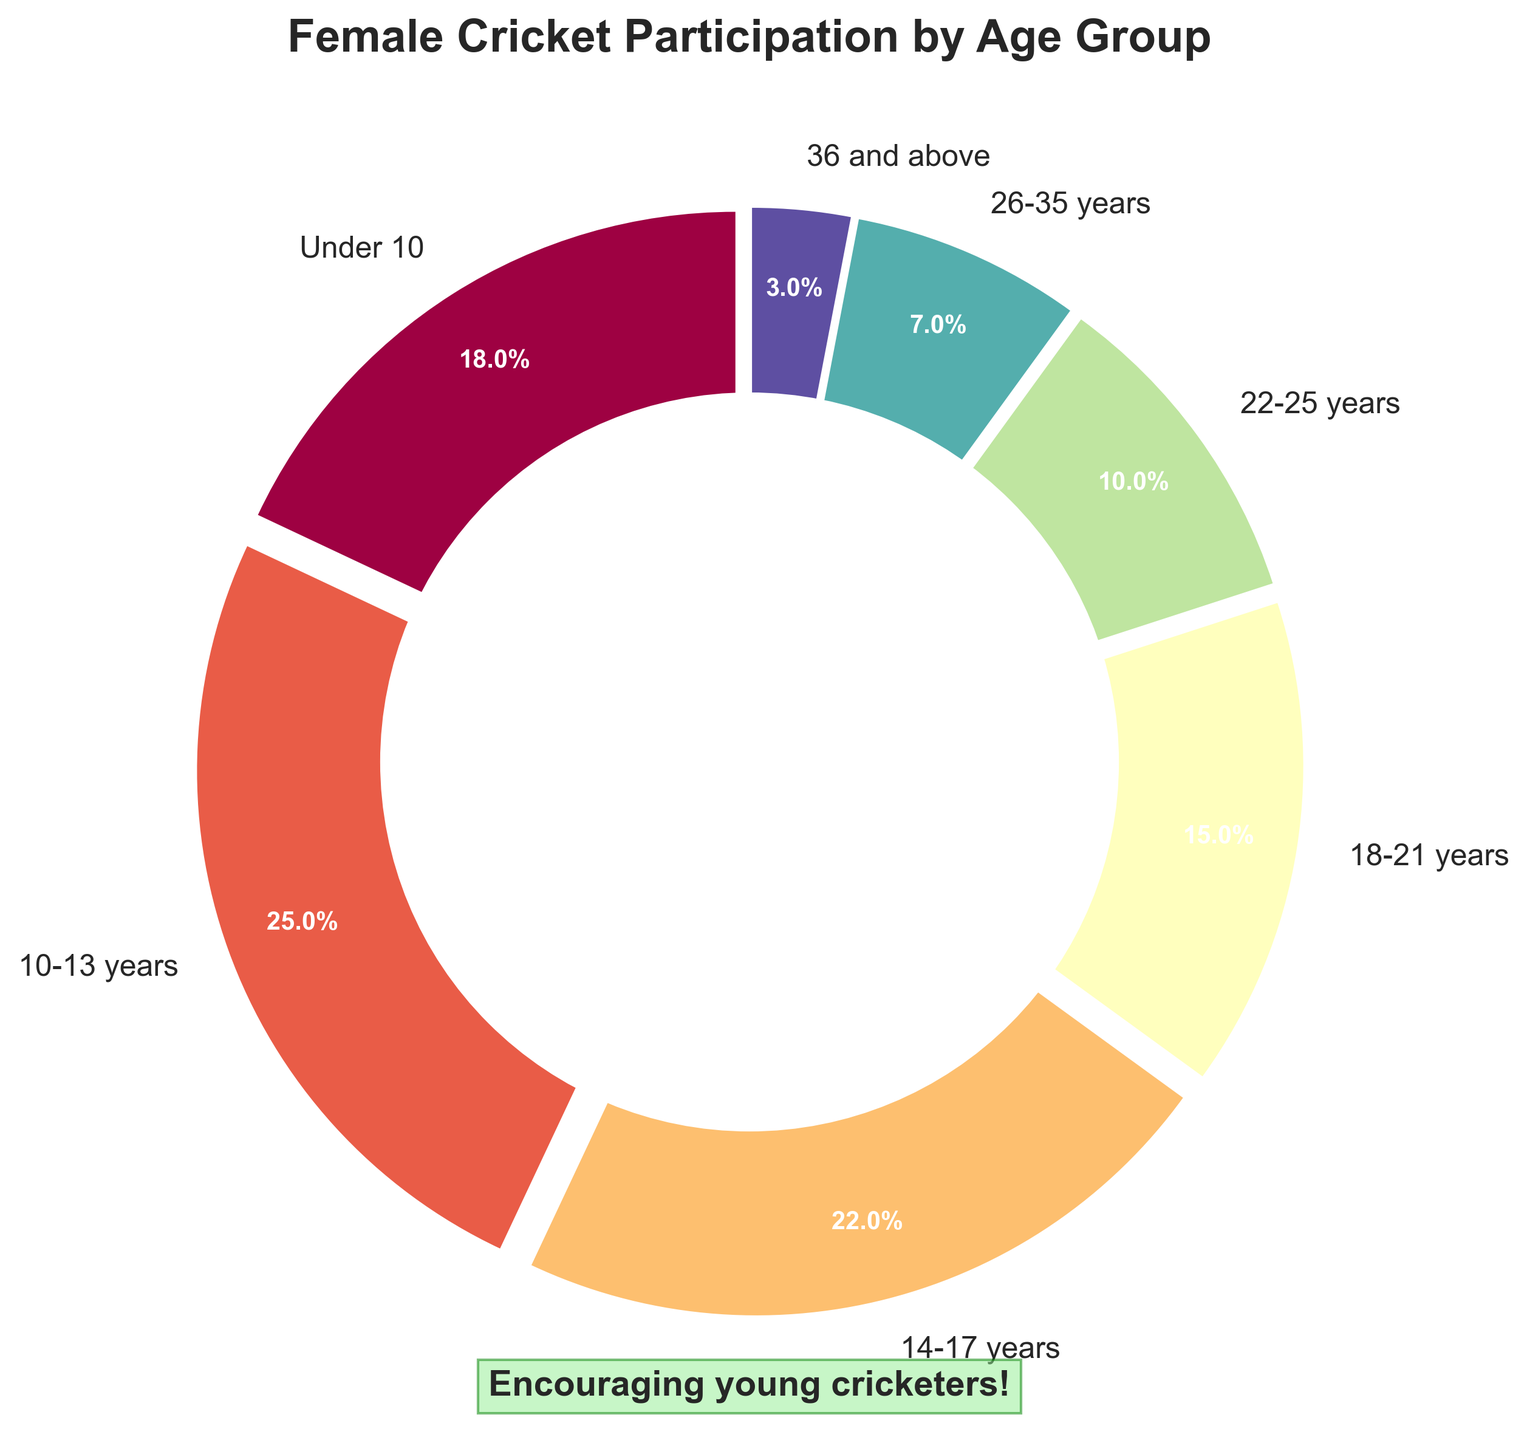What age group has the highest percentage of female cricket participation in local leagues? By looking at the pie chart, we can see that the age group "10-13 years" has the largest segment size and the highest percentage label.
Answer: 10-13 years What is the total percentage of female participation for the age groups under 18 years? We need to add the percentages of Under 10, 10-13 years, and 14-17 years: 18% + 25% + 22% = 65%.
Answer: 65% Which age group has a smaller percentage of participation, 18-21 years or 26-35 years? By comparing the segments, 18-21 years has 15% and 26-35 years has 7%. 7% is less than 15%.
Answer: 26-35 years What is the difference in percentage points between the age groups 14-17 years and 22-25 years? The percentage for 14-17 years is 22%, and for 22-25 years, it is 10%. The difference is 22% - 10% = 12%.
Answer: 12% Combine the percentages for the age groups 18-21 years and 22-25 years. What is the result? Add the percentages for 18-21 years (15%) and 22-25 years (10%): 15% + 10% = 25%.
Answer: 25% What is the color of the segment representing the age group "Under 10"? By visual inspection, the color of the "Under 10" segment is the first in the color sequence, noticeable for its distinct visual hue.
Answer: The color used in the chart Are there more participants in the age group 10-13 years than in the age groups 18-21 years and 36 and above combined? The percentage for 10-13 years is 25%, and the total for 18-21 years and 36 and above is 15% + 3% = 18%. 25% is greater than 18%.
Answer: Yes Which age group has the smallest percentage of female cricket participation? The pie chart segment for "36 and above" is the smallest and is labeled with the smallest percentage, 3%.
Answer: 36 and above By how much does female participation in the age group 22-25 years exceed the age group 36 and above? Compare the percentages for 22-25 years (10%) and 36 and above (3%). The difference is 10% - 3% = 7%.
Answer: 7% What fraction of participants is in the oldest age group (36 and above)? The percentage for the oldest age group is 3%. To convert this to a fraction: 3% = 3/100 = 3:100.
Answer: 3:100 